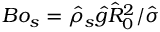<formula> <loc_0><loc_0><loc_500><loc_500>B o _ { s } = \hat { \rho } _ { s } \hat { g } { \hat { R } _ { 0 } } ^ { 2 } / \hat { \sigma }</formula> 